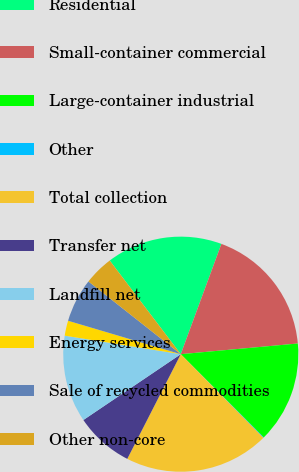Convert chart. <chart><loc_0><loc_0><loc_500><loc_500><pie_chart><fcel>Residential<fcel>Small-container commercial<fcel>Large-container industrial<fcel>Other<fcel>Total collection<fcel>Transfer net<fcel>Landfill net<fcel>Energy services<fcel>Sale of recycled commodities<fcel>Other non-core<nl><fcel>15.95%<fcel>17.93%<fcel>13.97%<fcel>0.08%<fcel>19.92%<fcel>8.02%<fcel>11.98%<fcel>2.07%<fcel>6.03%<fcel>4.05%<nl></chart> 